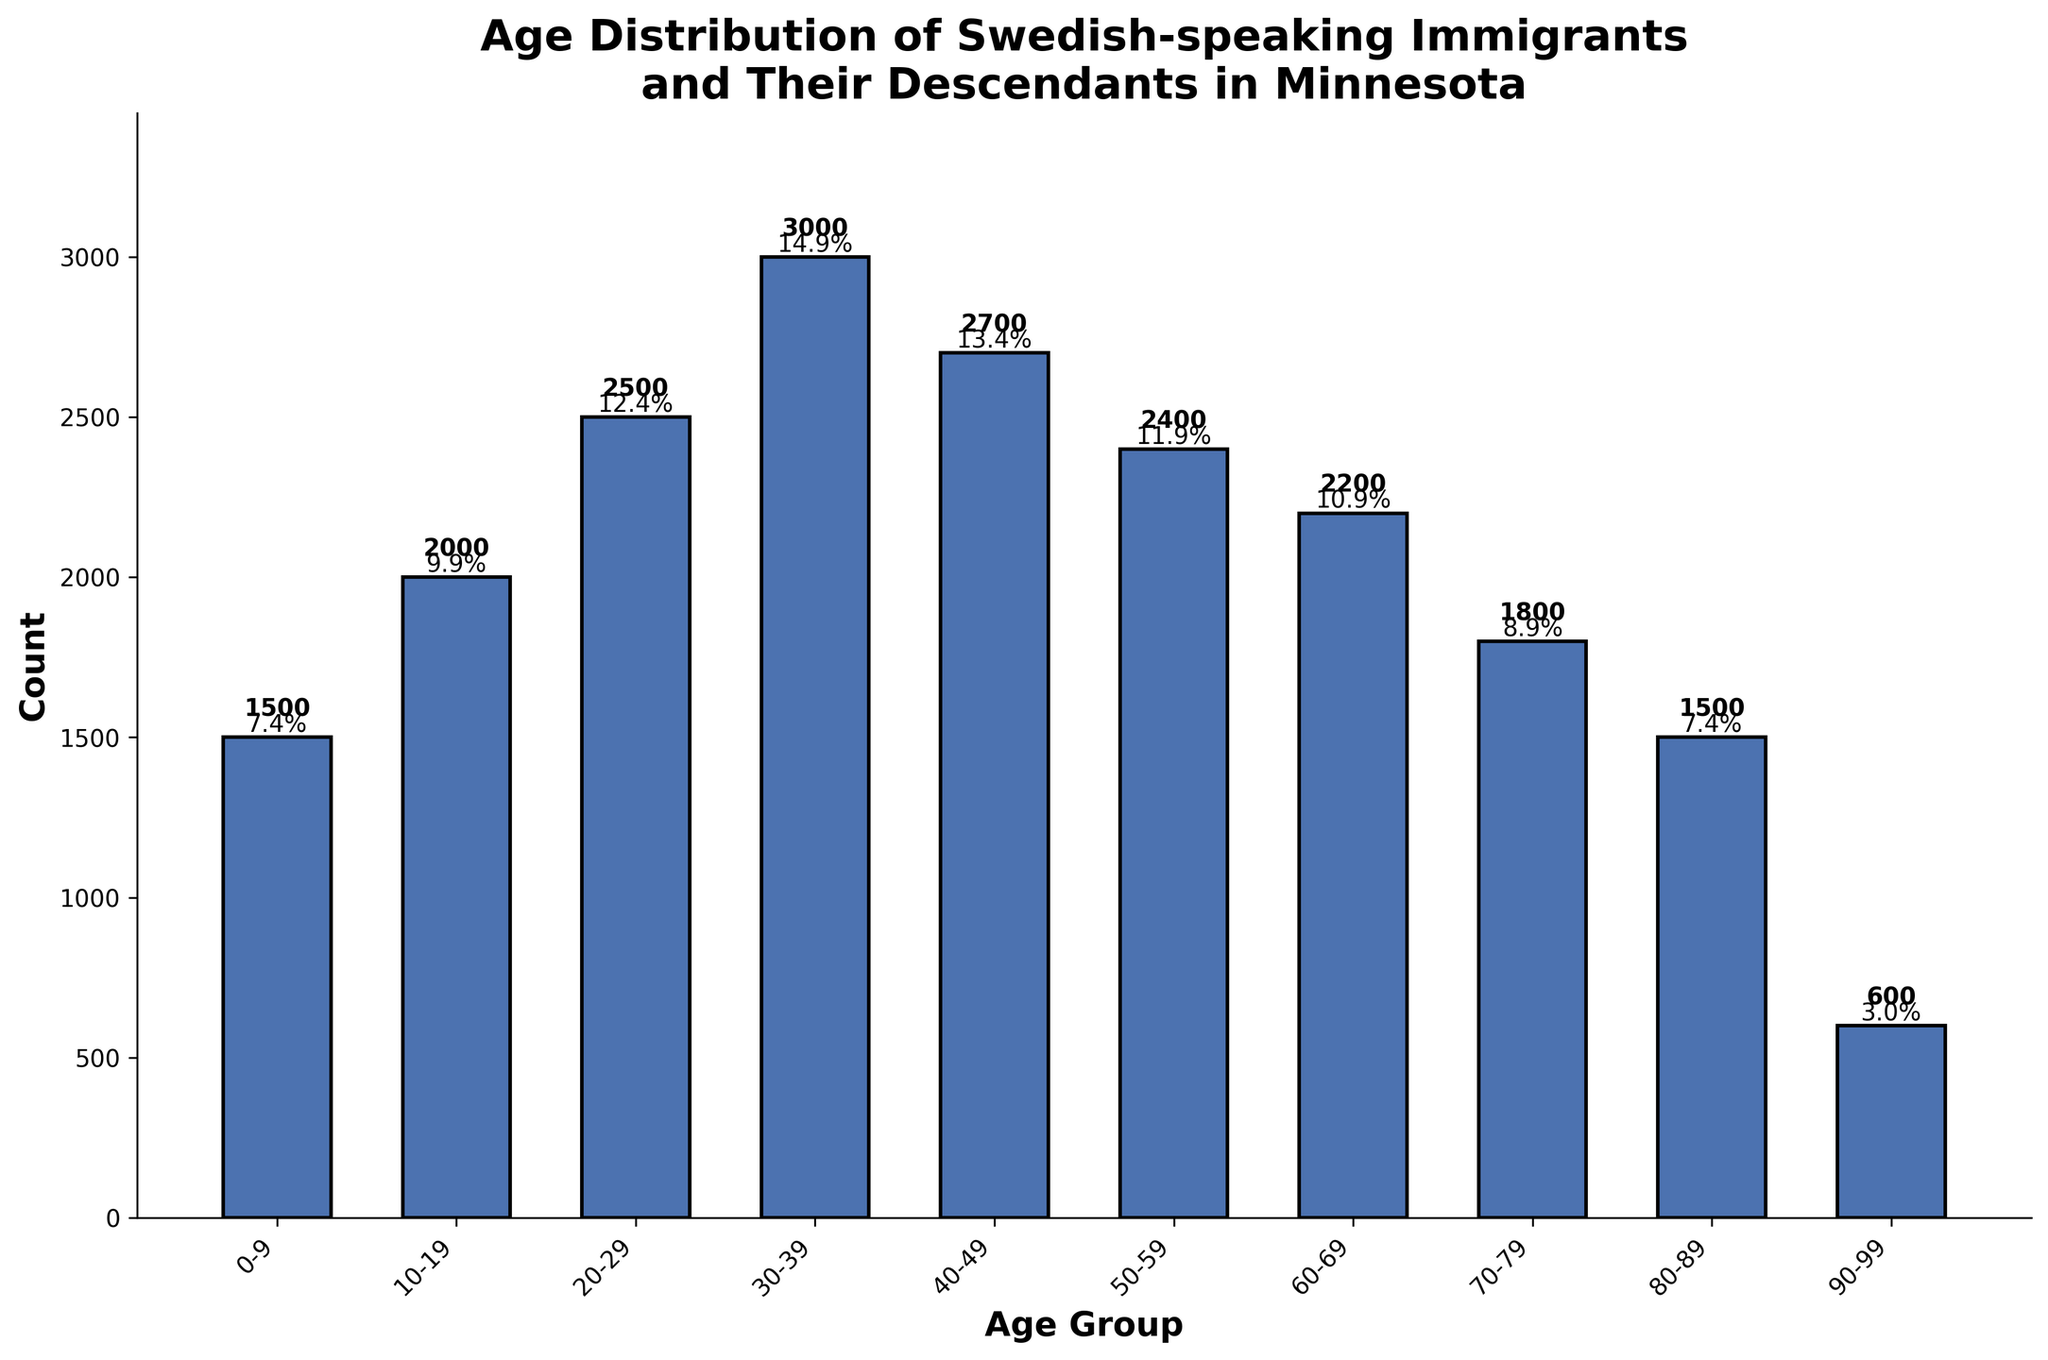What is the title of the distribution plot? The title of the distribution plot is located at the top center of the figure. It generally provides an overview of the data being presented. In this case, it is "Age Distribution of Swedish-speaking Immigrants and Their Descendants in Minnesota."
Answer: Age Distribution of Swedish-speaking Immigrants and Their Descendants in Minnesota Which age group has the highest count? To determine the age group with the highest count, look at the tallest bar in the plot. The tallest bar is the one corresponding to the age group 30-39, indicating that it has the highest count.
Answer: 30-39 What is the total count of Swedish-speaking immigrants and their descendants in Minnesota? To find the total count, sum the counts for all age groups: 1500 (0-9) + 2000 (10-19) + 2500 (20-29) + 3000 (30-39) + 2700 (40-49) + 2400 (50-59) + 2200 (60-69) + 1800 (70-79) + 1500 (80-89) + 600 (90-99) = 22200.
Answer: 22200 What percentage of the total population is in the age group 50-59? First, identify the count for the age group 50-59 which is 2400. Then calculate the percentage: (2400 / 22200) * 100 ≈ 10.8%.
Answer: 10.8% How does the count of the age group 70-79 compare to the count of the age group 80-89? To compare, we look at the counts: 1800 for the age group 70-79 and 1500 for the age group 80-89. The count for the age group 70-79 is greater than the count for the age group 80-89.
Answer: Greater than Which age group has the lowest count, and what is the number? To identify the age group with the lowest count, look for the shortest bar in the plot. The shortest bar corresponds to the age group 90-99 with a count of 600.
Answer: 90-99, 600 What is the combined count of age groups 10-19 and 20-29? To find the combined count, add the counts for age groups 10-19 and 20-29: 2000 (10-19) + 2500 (20-29) = 4500.
Answer: 4500 What is the average count per age group? Calculate the average count by dividing the total count (22200) by the number of age groups (10): 22200 / 10 = 2220.
Answer: 2220 What is the combined percentage of the total population for age groups 0-9, 10-19, and 20-29? First find the total count for these groups: 1500 (0-9) + 2000 (10-19) + 2500 (20-29) = 6000. Then calculate the percentage: (6000 / 22200) * 100 ≈ 27.0%.
Answer: 27.0% How does the count of the age group 40-49 compare to the average count across all age groups? The count for the age group 40-49 is 2700, and the average count across all age groups is 2220. Hence, the count for the age group 40-49 is greater than the average count.
Answer: Greater than 